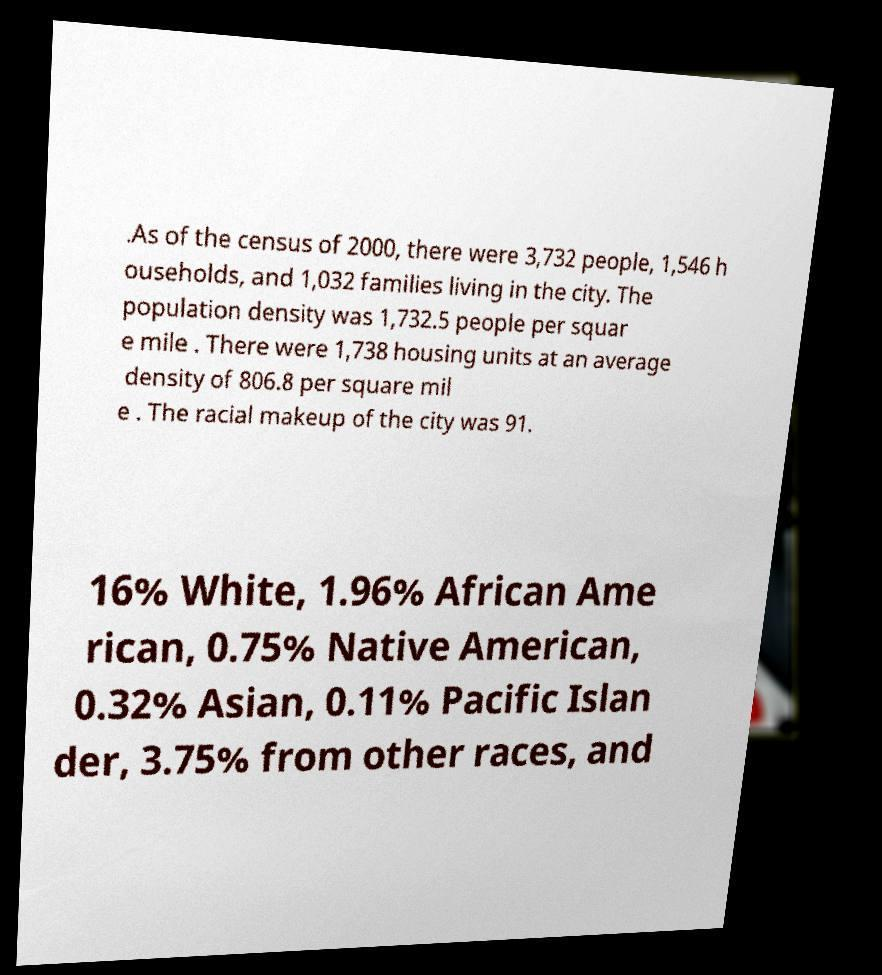Could you extract and type out the text from this image? .As of the census of 2000, there were 3,732 people, 1,546 h ouseholds, and 1,032 families living in the city. The population density was 1,732.5 people per squar e mile . There were 1,738 housing units at an average density of 806.8 per square mil e . The racial makeup of the city was 91. 16% White, 1.96% African Ame rican, 0.75% Native American, 0.32% Asian, 0.11% Pacific Islan der, 3.75% from other races, and 